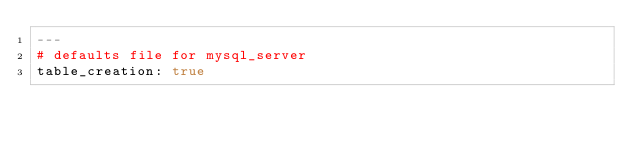<code> <loc_0><loc_0><loc_500><loc_500><_YAML_>---
# defaults file for mysql_server
table_creation: true
</code> 